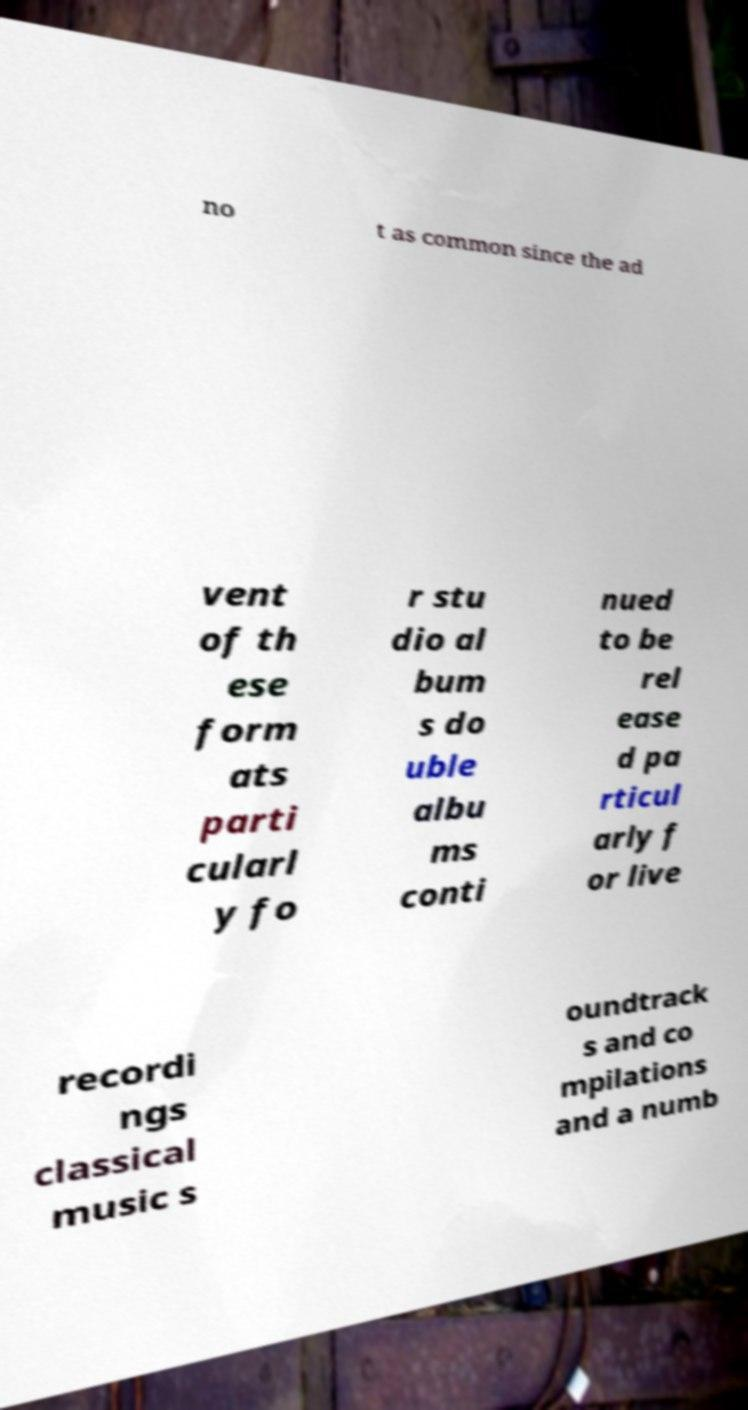There's text embedded in this image that I need extracted. Can you transcribe it verbatim? no t as common since the ad vent of th ese form ats parti cularl y fo r stu dio al bum s do uble albu ms conti nued to be rel ease d pa rticul arly f or live recordi ngs classical music s oundtrack s and co mpilations and a numb 